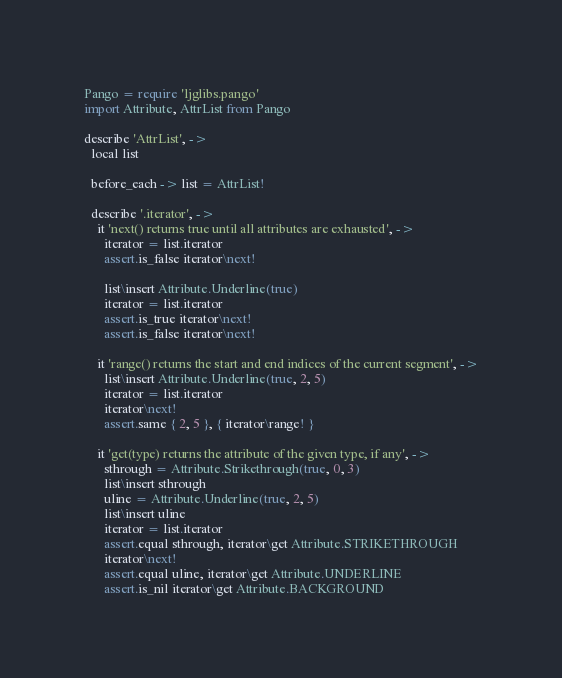<code> <loc_0><loc_0><loc_500><loc_500><_MoonScript_>Pango = require 'ljglibs.pango'
import Attribute, AttrList from Pango

describe 'AttrList', ->
  local list

  before_each -> list = AttrList!

  describe '.iterator', ->
    it 'next() returns true until all attributes are exhausted', ->
      iterator = list.iterator
      assert.is_false iterator\next!

      list\insert Attribute.Underline(true)
      iterator = list.iterator
      assert.is_true iterator\next!
      assert.is_false iterator\next!

    it 'range() returns the start and end indices of the current segment', ->
      list\insert Attribute.Underline(true, 2, 5)
      iterator = list.iterator
      iterator\next!
      assert.same { 2, 5 }, { iterator\range! }

    it 'get(type) returns the attribute of the given type, if any', ->
      sthrough = Attribute.Strikethrough(true, 0, 3)
      list\insert sthrough
      uline = Attribute.Underline(true, 2, 5)
      list\insert uline
      iterator = list.iterator
      assert.equal sthrough, iterator\get Attribute.STRIKETHROUGH
      iterator\next!
      assert.equal uline, iterator\get Attribute.UNDERLINE
      assert.is_nil iterator\get Attribute.BACKGROUND
</code> 